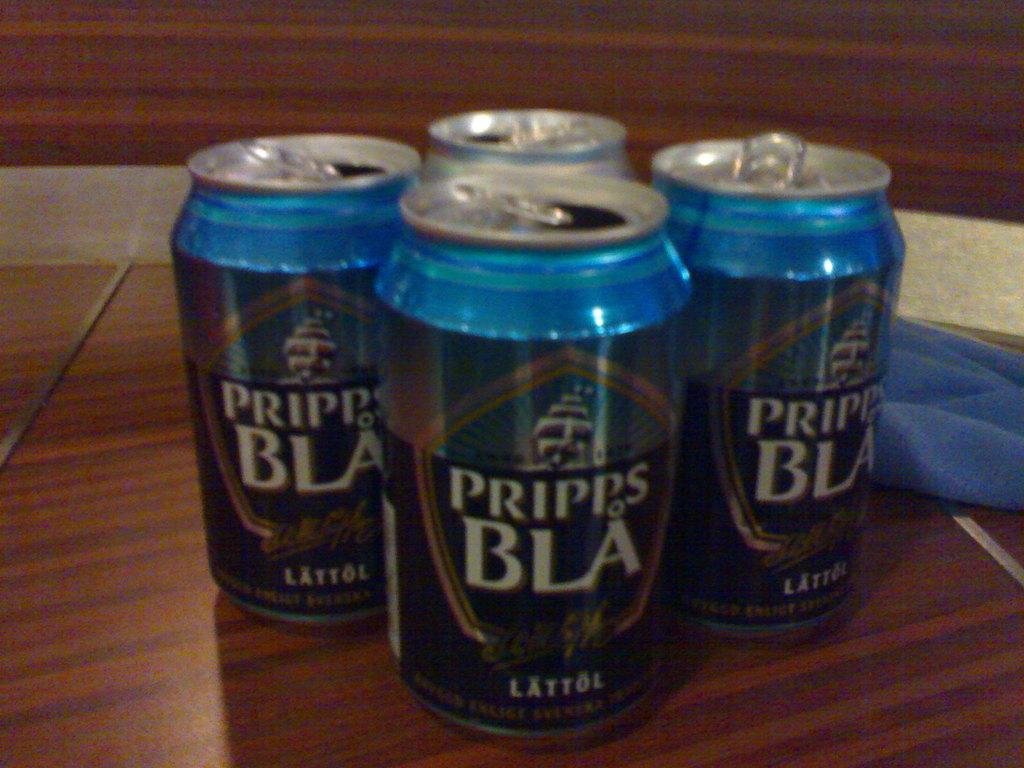<image>
Describe the image concisely. Four cans of Pripps BLA are open on a wooden tabletop. 